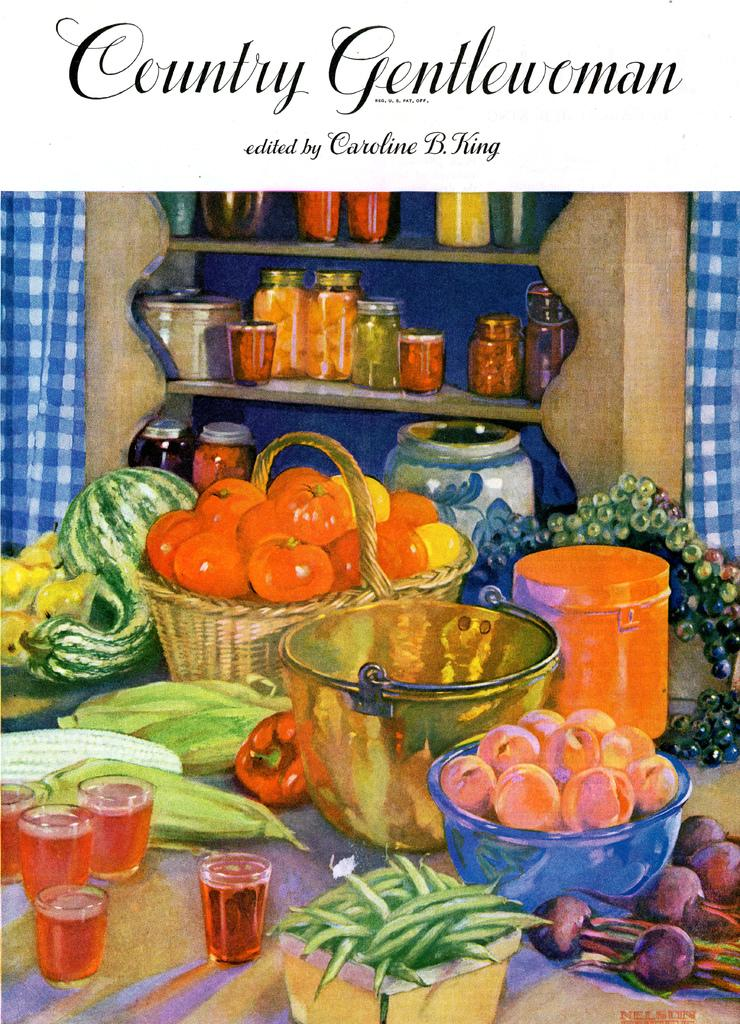What type of image is being described? The image is a poster. What is depicted on the poster? There are vegetables and fruits on the poster. Where are the vegetables and fruits located on the poster? The vegetables and fruits are on a table. Is there any text on the poster? Yes, there is text at the top of the poster. Can you tell me how many people are driving in the image? There are no people driving in the image, as it is a poster featuring vegetables and fruits on a table. What type of soup is being prepared with the celery in the image? There is no soup or celery present in the image; it features vegetables and fruits on a table. 